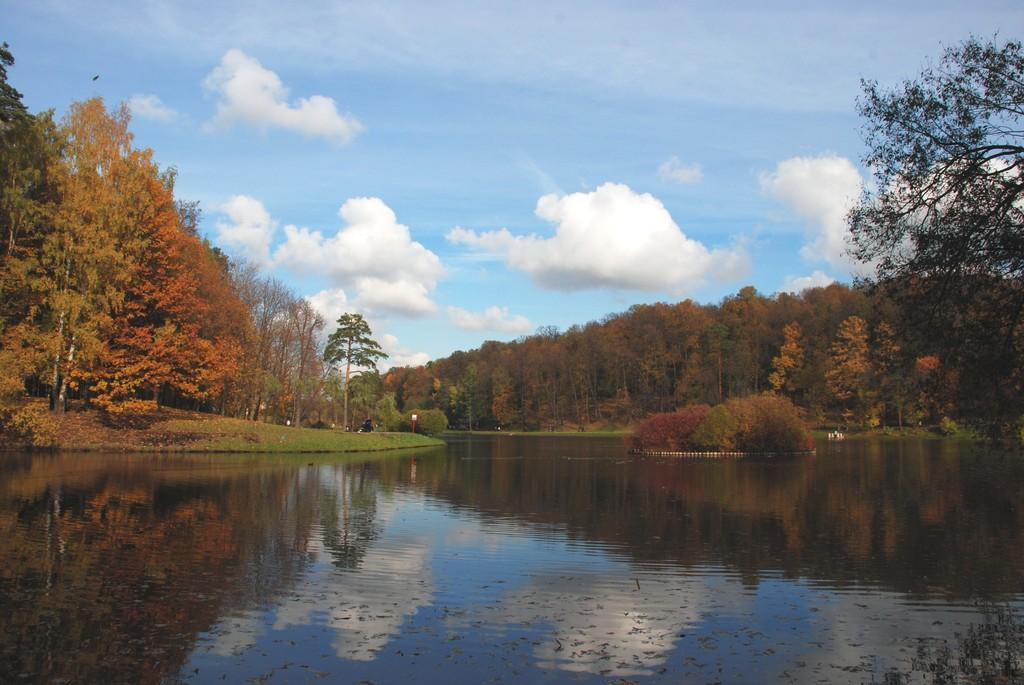What is the primary element visible in the image? There is water in the image. What type of vegetation can be seen in the image? There are trees in the image. What else is present in the image besides water and trees? There are objects in the image. What can be seen in the background of the image? The sky is visible in the background of the image. What is the weather like in the image? The presence of clouds in the sky suggests that it might be partly cloudy. What type of fork can be seen in the image? There is no fork present in the image. What type of ray is visible in the image? There is no ray visible in the image. 